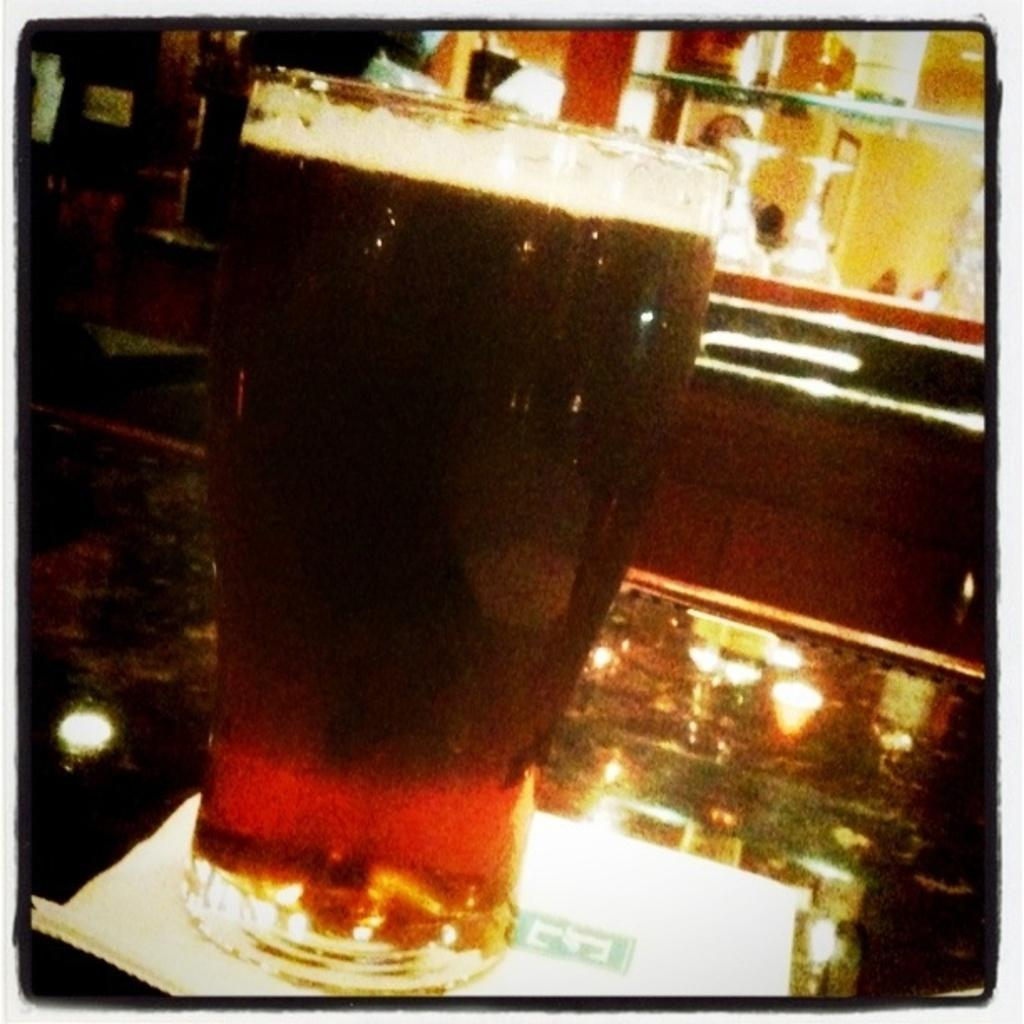What is on the table in the image? There is a glass on the table in the image. What is on the glass? There is a paper napkin on the glass in the image. What is the table made of? The table is made of glass. What can be seen on the shelves in the image? There are glasses on the shelves in the image. What type of cheese is on the table in the image? There is no cheese present in the image. Can you tell me how many sisters are visible in the image? There are no people, including sisters, present in the image. 